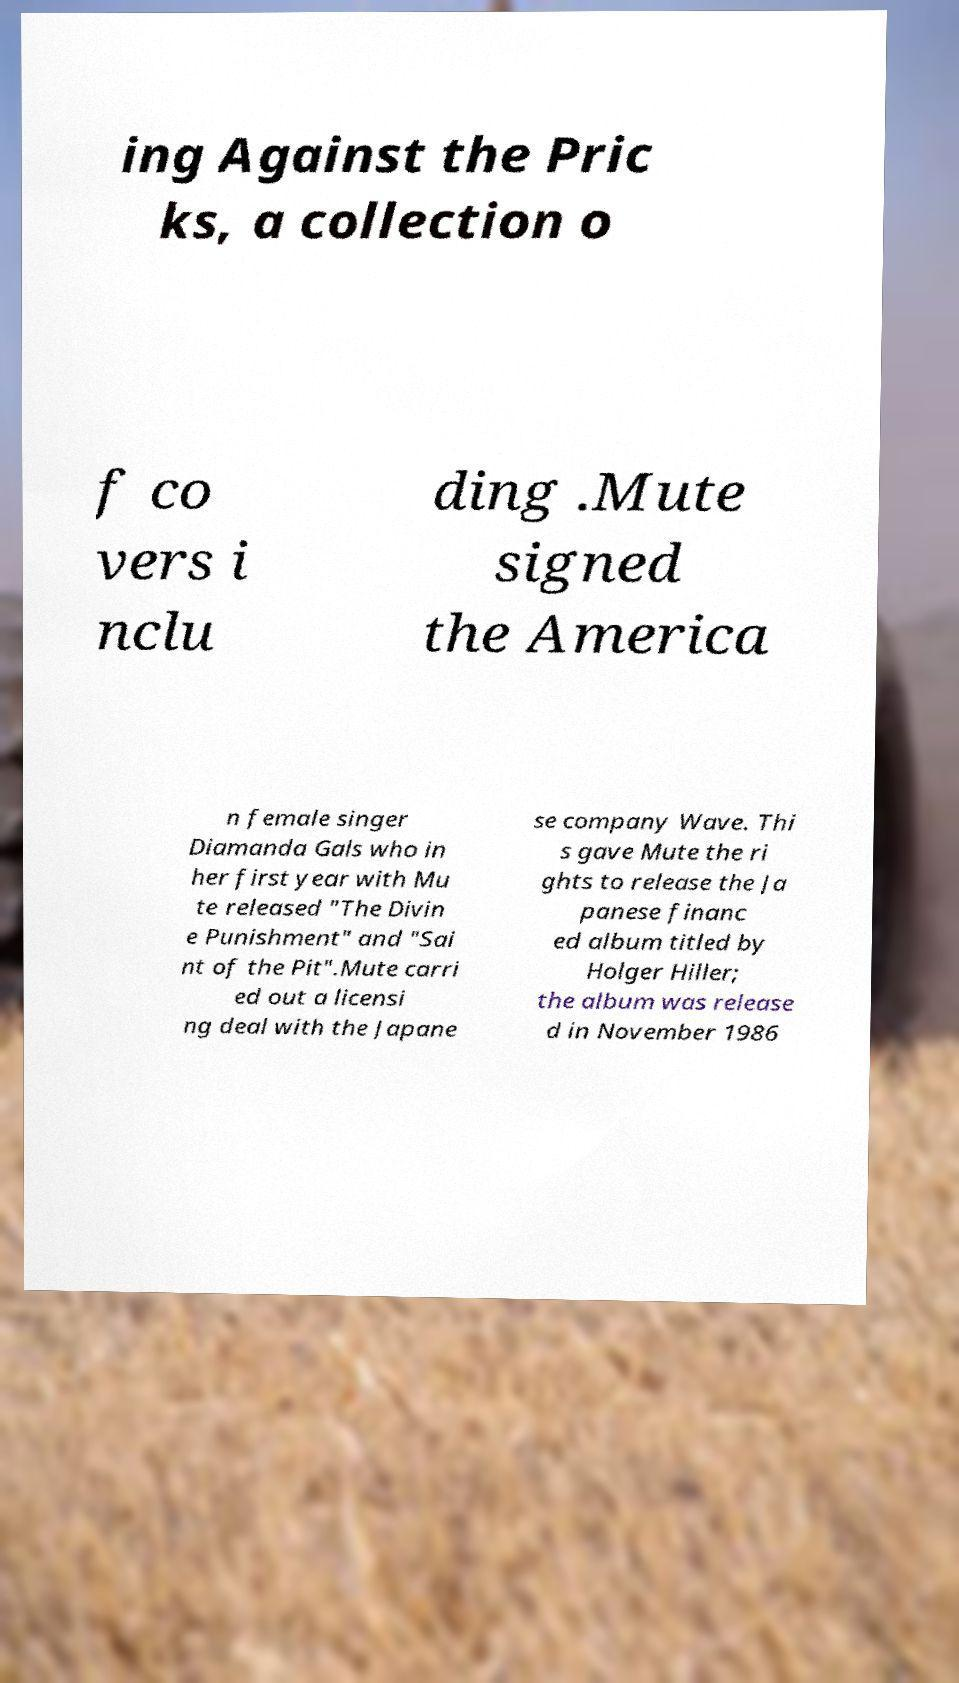For documentation purposes, I need the text within this image transcribed. Could you provide that? ing Against the Pric ks, a collection o f co vers i nclu ding .Mute signed the America n female singer Diamanda Gals who in her first year with Mu te released "The Divin e Punishment" and "Sai nt of the Pit".Mute carri ed out a licensi ng deal with the Japane se company Wave. Thi s gave Mute the ri ghts to release the Ja panese financ ed album titled by Holger Hiller; the album was release d in November 1986 